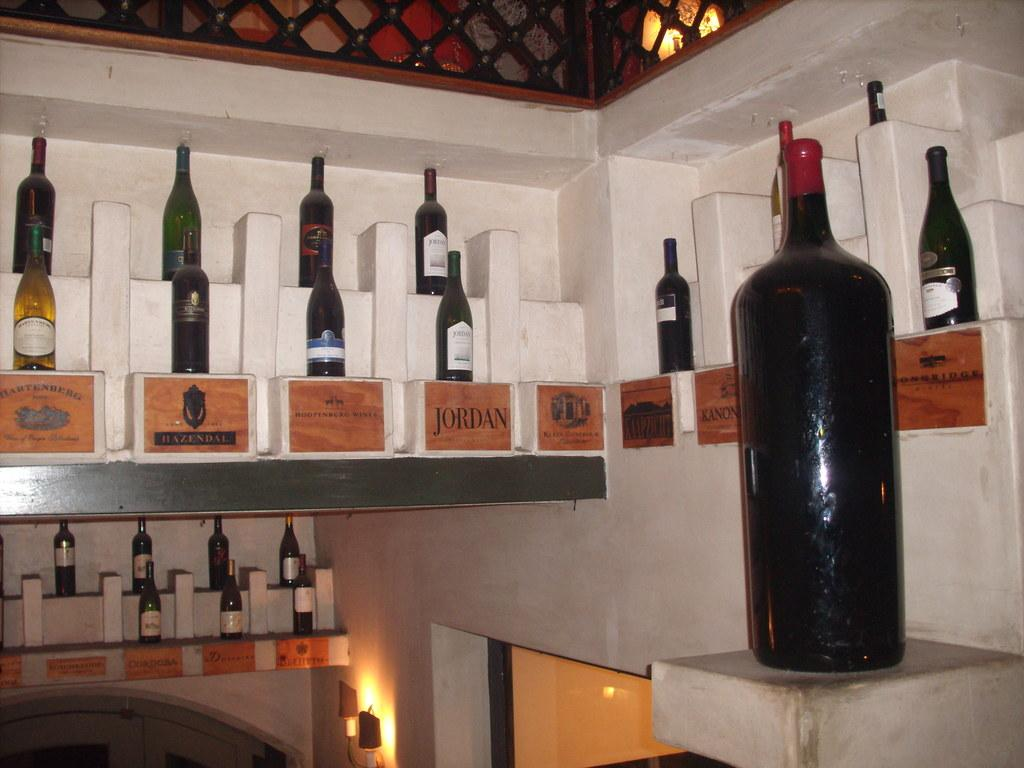Provide a one-sentence caption for the provided image. Several wine bottles are shown with a wooden sign below denoting the brand such as "Hoopenburg Wines.". 